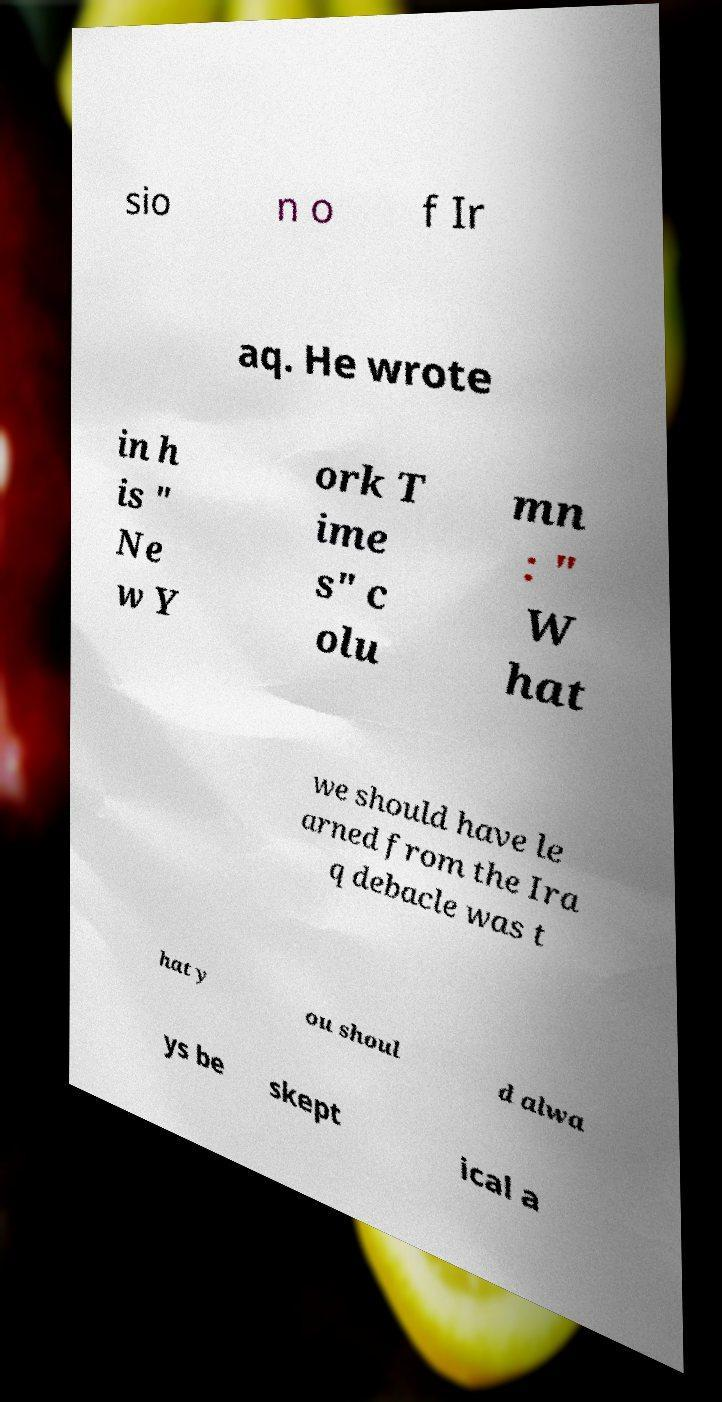Please identify and transcribe the text found in this image. sio n o f Ir aq. He wrote in h is " Ne w Y ork T ime s" c olu mn : " W hat we should have le arned from the Ira q debacle was t hat y ou shoul d alwa ys be skept ical a 